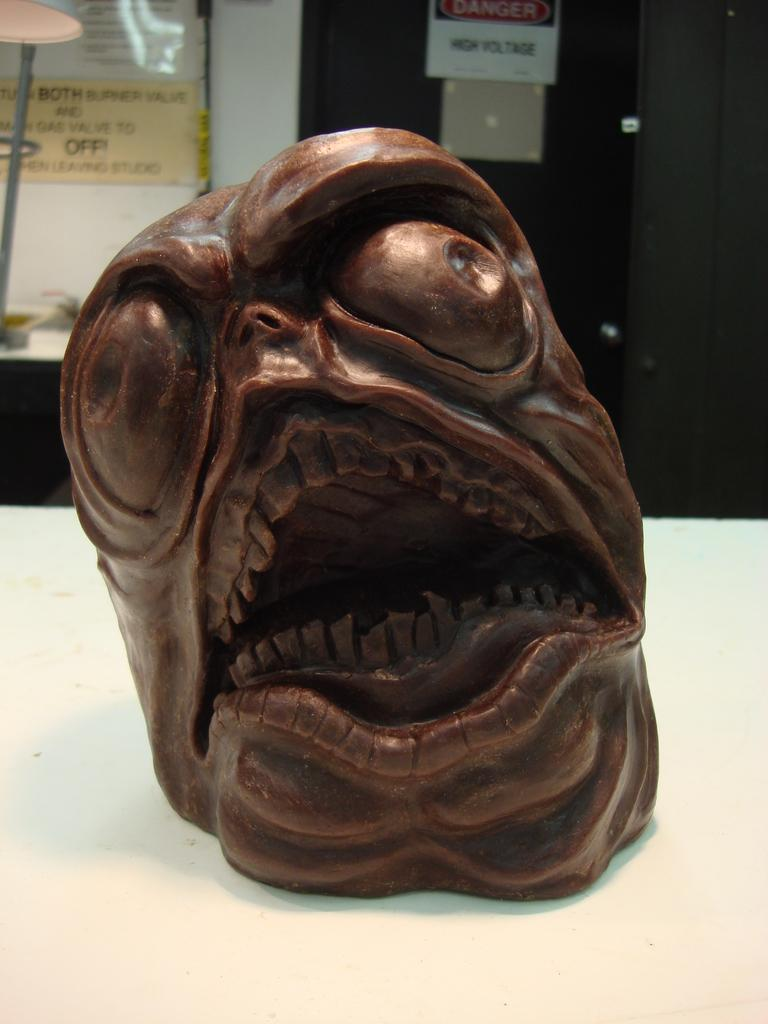What is the main subject on the table in the image? There is a sculpture on a table in the image. What other items can be seen in the image besides the sculpture? There are posters in the image. Can you describe the posters in the image? The posters have text visible on them. What type of authority figure is depicted in the sculpture? There is no authority figure depicted in the sculpture; it is a sculpture and not a representation of a person. 